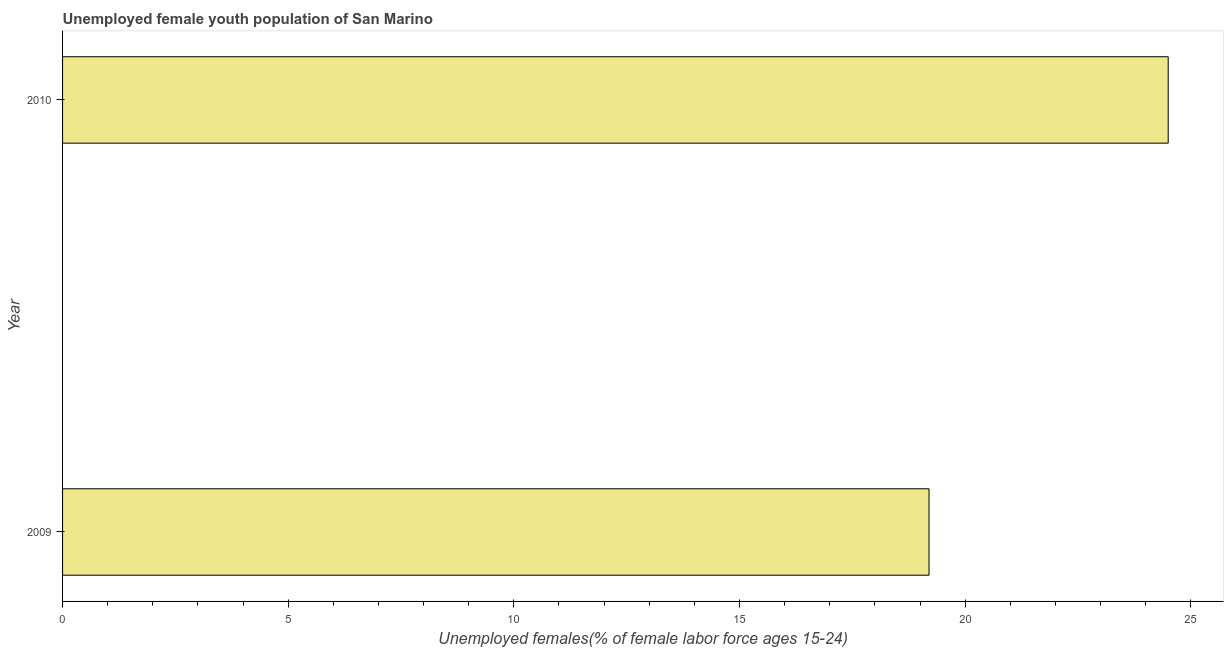What is the title of the graph?
Your answer should be very brief. Unemployed female youth population of San Marino. What is the label or title of the X-axis?
Provide a short and direct response. Unemployed females(% of female labor force ages 15-24). What is the label or title of the Y-axis?
Offer a terse response. Year. What is the unemployed female youth in 2010?
Your answer should be compact. 24.5. Across all years, what is the maximum unemployed female youth?
Offer a very short reply. 24.5. Across all years, what is the minimum unemployed female youth?
Make the answer very short. 19.2. In which year was the unemployed female youth maximum?
Provide a short and direct response. 2010. What is the sum of the unemployed female youth?
Give a very brief answer. 43.7. What is the difference between the unemployed female youth in 2009 and 2010?
Offer a very short reply. -5.3. What is the average unemployed female youth per year?
Your response must be concise. 21.85. What is the median unemployed female youth?
Offer a terse response. 21.85. In how many years, is the unemployed female youth greater than 21 %?
Offer a terse response. 1. What is the ratio of the unemployed female youth in 2009 to that in 2010?
Provide a short and direct response. 0.78. How many bars are there?
Make the answer very short. 2. What is the difference between two consecutive major ticks on the X-axis?
Your answer should be compact. 5. Are the values on the major ticks of X-axis written in scientific E-notation?
Your response must be concise. No. What is the Unemployed females(% of female labor force ages 15-24) of 2009?
Give a very brief answer. 19.2. What is the Unemployed females(% of female labor force ages 15-24) in 2010?
Your answer should be very brief. 24.5. What is the ratio of the Unemployed females(% of female labor force ages 15-24) in 2009 to that in 2010?
Provide a short and direct response. 0.78. 